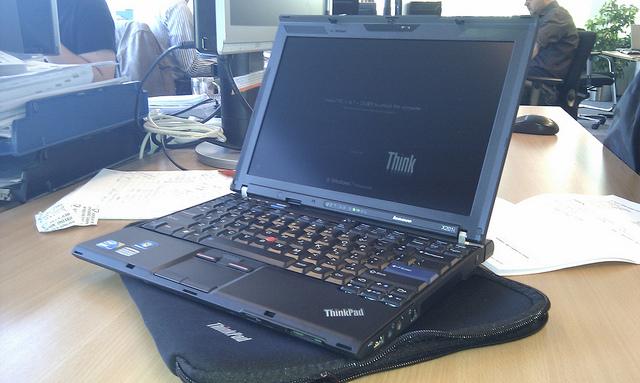Is this device easily transported?
Answer briefly. Yes. Is the laptop on or off?
Answer briefly. On. What is the object the laptop in front center laying on top of?
Give a very brief answer. Laptop case. 